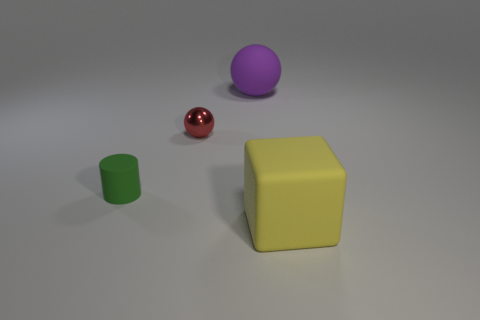Subtract 1 balls. How many balls are left? 1 Add 2 yellow objects. How many yellow objects exist? 3 Add 1 big yellow matte cubes. How many objects exist? 5 Subtract all purple spheres. How many spheres are left? 1 Subtract 0 brown balls. How many objects are left? 4 Subtract all cubes. How many objects are left? 3 Subtract all blue cylinders. Subtract all cyan cubes. How many cylinders are left? 1 Subtract all brown cylinders. How many green blocks are left? 0 Subtract all small yellow metal balls. Subtract all green objects. How many objects are left? 3 Add 3 purple things. How many purple things are left? 4 